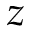Convert formula to latex. <formula><loc_0><loc_0><loc_500><loc_500>z</formula> 